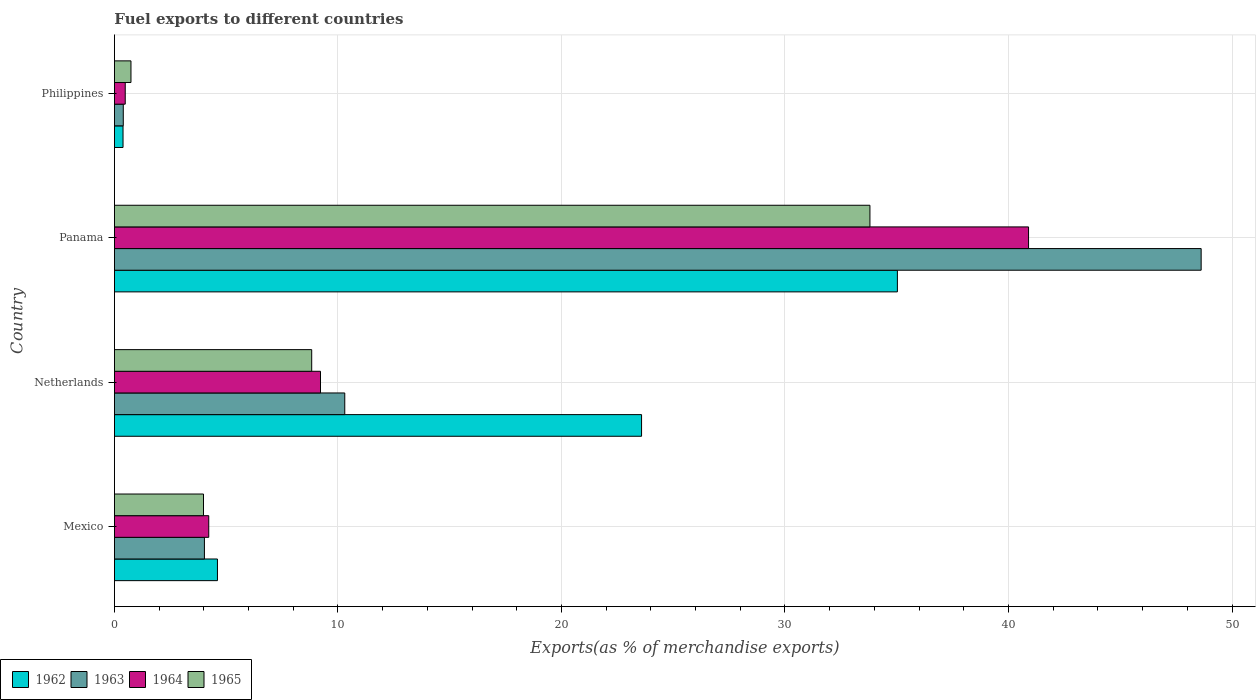How many different coloured bars are there?
Give a very brief answer. 4. Are the number of bars on each tick of the Y-axis equal?
Your answer should be compact. Yes. What is the label of the 1st group of bars from the top?
Give a very brief answer. Philippines. What is the percentage of exports to different countries in 1962 in Mexico?
Give a very brief answer. 4.61. Across all countries, what is the maximum percentage of exports to different countries in 1963?
Make the answer very short. 48.62. Across all countries, what is the minimum percentage of exports to different countries in 1962?
Ensure brevity in your answer.  0.38. In which country was the percentage of exports to different countries in 1964 maximum?
Provide a short and direct response. Panama. What is the total percentage of exports to different countries in 1963 in the graph?
Provide a short and direct response. 63.35. What is the difference between the percentage of exports to different countries in 1963 in Netherlands and that in Philippines?
Your response must be concise. 9.91. What is the difference between the percentage of exports to different countries in 1963 in Panama and the percentage of exports to different countries in 1962 in Netherlands?
Keep it short and to the point. 25.04. What is the average percentage of exports to different countries in 1965 per country?
Make the answer very short. 11.84. What is the difference between the percentage of exports to different countries in 1965 and percentage of exports to different countries in 1962 in Mexico?
Give a very brief answer. -0.62. What is the ratio of the percentage of exports to different countries in 1964 in Netherlands to that in Philippines?
Ensure brevity in your answer.  19.07. Is the percentage of exports to different countries in 1963 in Netherlands less than that in Philippines?
Offer a terse response. No. What is the difference between the highest and the second highest percentage of exports to different countries in 1965?
Offer a terse response. 24.98. What is the difference between the highest and the lowest percentage of exports to different countries in 1965?
Give a very brief answer. 33.06. Is it the case that in every country, the sum of the percentage of exports to different countries in 1965 and percentage of exports to different countries in 1964 is greater than the sum of percentage of exports to different countries in 1963 and percentage of exports to different countries in 1962?
Give a very brief answer. No. What does the 2nd bar from the top in Panama represents?
Keep it short and to the point. 1964. What does the 4th bar from the bottom in Philippines represents?
Keep it short and to the point. 1965. Are all the bars in the graph horizontal?
Ensure brevity in your answer.  Yes. How many countries are there in the graph?
Ensure brevity in your answer.  4. What is the difference between two consecutive major ticks on the X-axis?
Make the answer very short. 10. Are the values on the major ticks of X-axis written in scientific E-notation?
Ensure brevity in your answer.  No. Does the graph contain any zero values?
Make the answer very short. No. How many legend labels are there?
Your response must be concise. 4. How are the legend labels stacked?
Offer a very short reply. Horizontal. What is the title of the graph?
Your answer should be very brief. Fuel exports to different countries. Does "1985" appear as one of the legend labels in the graph?
Your answer should be very brief. No. What is the label or title of the X-axis?
Your response must be concise. Exports(as % of merchandise exports). What is the label or title of the Y-axis?
Provide a succinct answer. Country. What is the Exports(as % of merchandise exports) of 1962 in Mexico?
Offer a terse response. 4.61. What is the Exports(as % of merchandise exports) in 1963 in Mexico?
Give a very brief answer. 4.03. What is the Exports(as % of merchandise exports) of 1964 in Mexico?
Your response must be concise. 4.22. What is the Exports(as % of merchandise exports) of 1965 in Mexico?
Your answer should be compact. 3.99. What is the Exports(as % of merchandise exports) of 1962 in Netherlands?
Ensure brevity in your answer.  23.58. What is the Exports(as % of merchandise exports) of 1963 in Netherlands?
Offer a very short reply. 10.31. What is the Exports(as % of merchandise exports) of 1964 in Netherlands?
Provide a succinct answer. 9.22. What is the Exports(as % of merchandise exports) in 1965 in Netherlands?
Offer a very short reply. 8.83. What is the Exports(as % of merchandise exports) of 1962 in Panama?
Give a very brief answer. 35.03. What is the Exports(as % of merchandise exports) of 1963 in Panama?
Your answer should be very brief. 48.62. What is the Exports(as % of merchandise exports) of 1964 in Panama?
Make the answer very short. 40.9. What is the Exports(as % of merchandise exports) of 1965 in Panama?
Offer a terse response. 33.8. What is the Exports(as % of merchandise exports) in 1962 in Philippines?
Keep it short and to the point. 0.38. What is the Exports(as % of merchandise exports) of 1963 in Philippines?
Your answer should be compact. 0.4. What is the Exports(as % of merchandise exports) in 1964 in Philippines?
Your answer should be compact. 0.48. What is the Exports(as % of merchandise exports) in 1965 in Philippines?
Your answer should be very brief. 0.74. Across all countries, what is the maximum Exports(as % of merchandise exports) of 1962?
Your answer should be compact. 35.03. Across all countries, what is the maximum Exports(as % of merchandise exports) of 1963?
Offer a terse response. 48.62. Across all countries, what is the maximum Exports(as % of merchandise exports) of 1964?
Make the answer very short. 40.9. Across all countries, what is the maximum Exports(as % of merchandise exports) of 1965?
Give a very brief answer. 33.8. Across all countries, what is the minimum Exports(as % of merchandise exports) in 1962?
Offer a terse response. 0.38. Across all countries, what is the minimum Exports(as % of merchandise exports) in 1963?
Offer a terse response. 0.4. Across all countries, what is the minimum Exports(as % of merchandise exports) in 1964?
Offer a very short reply. 0.48. Across all countries, what is the minimum Exports(as % of merchandise exports) in 1965?
Your answer should be compact. 0.74. What is the total Exports(as % of merchandise exports) of 1962 in the graph?
Provide a succinct answer. 63.61. What is the total Exports(as % of merchandise exports) in 1963 in the graph?
Offer a very short reply. 63.35. What is the total Exports(as % of merchandise exports) in 1964 in the graph?
Your answer should be compact. 54.82. What is the total Exports(as % of merchandise exports) in 1965 in the graph?
Keep it short and to the point. 47.35. What is the difference between the Exports(as % of merchandise exports) in 1962 in Mexico and that in Netherlands?
Offer a very short reply. -18.97. What is the difference between the Exports(as % of merchandise exports) in 1963 in Mexico and that in Netherlands?
Provide a succinct answer. -6.28. What is the difference between the Exports(as % of merchandise exports) in 1964 in Mexico and that in Netherlands?
Your answer should be compact. -5. What is the difference between the Exports(as % of merchandise exports) of 1965 in Mexico and that in Netherlands?
Provide a short and direct response. -4.84. What is the difference between the Exports(as % of merchandise exports) of 1962 in Mexico and that in Panama?
Offer a very short reply. -30.42. What is the difference between the Exports(as % of merchandise exports) in 1963 in Mexico and that in Panama?
Your answer should be compact. -44.59. What is the difference between the Exports(as % of merchandise exports) in 1964 in Mexico and that in Panama?
Provide a succinct answer. -36.68. What is the difference between the Exports(as % of merchandise exports) in 1965 in Mexico and that in Panama?
Your answer should be very brief. -29.82. What is the difference between the Exports(as % of merchandise exports) of 1962 in Mexico and that in Philippines?
Your answer should be compact. 4.22. What is the difference between the Exports(as % of merchandise exports) of 1963 in Mexico and that in Philippines?
Your response must be concise. 3.63. What is the difference between the Exports(as % of merchandise exports) in 1964 in Mexico and that in Philippines?
Offer a very short reply. 3.74. What is the difference between the Exports(as % of merchandise exports) in 1965 in Mexico and that in Philippines?
Make the answer very short. 3.25. What is the difference between the Exports(as % of merchandise exports) in 1962 in Netherlands and that in Panama?
Keep it short and to the point. -11.45. What is the difference between the Exports(as % of merchandise exports) in 1963 in Netherlands and that in Panama?
Offer a terse response. -38.32. What is the difference between the Exports(as % of merchandise exports) in 1964 in Netherlands and that in Panama?
Your answer should be very brief. -31.68. What is the difference between the Exports(as % of merchandise exports) of 1965 in Netherlands and that in Panama?
Make the answer very short. -24.98. What is the difference between the Exports(as % of merchandise exports) in 1962 in Netherlands and that in Philippines?
Your response must be concise. 23.2. What is the difference between the Exports(as % of merchandise exports) of 1963 in Netherlands and that in Philippines?
Offer a very short reply. 9.91. What is the difference between the Exports(as % of merchandise exports) of 1964 in Netherlands and that in Philippines?
Your response must be concise. 8.74. What is the difference between the Exports(as % of merchandise exports) in 1965 in Netherlands and that in Philippines?
Make the answer very short. 8.09. What is the difference between the Exports(as % of merchandise exports) in 1962 in Panama and that in Philippines?
Ensure brevity in your answer.  34.65. What is the difference between the Exports(as % of merchandise exports) in 1963 in Panama and that in Philippines?
Your response must be concise. 48.22. What is the difference between the Exports(as % of merchandise exports) in 1964 in Panama and that in Philippines?
Your response must be concise. 40.41. What is the difference between the Exports(as % of merchandise exports) in 1965 in Panama and that in Philippines?
Your answer should be very brief. 33.06. What is the difference between the Exports(as % of merchandise exports) in 1962 in Mexico and the Exports(as % of merchandise exports) in 1963 in Netherlands?
Ensure brevity in your answer.  -5.7. What is the difference between the Exports(as % of merchandise exports) in 1962 in Mexico and the Exports(as % of merchandise exports) in 1964 in Netherlands?
Keep it short and to the point. -4.61. What is the difference between the Exports(as % of merchandise exports) of 1962 in Mexico and the Exports(as % of merchandise exports) of 1965 in Netherlands?
Make the answer very short. -4.22. What is the difference between the Exports(as % of merchandise exports) of 1963 in Mexico and the Exports(as % of merchandise exports) of 1964 in Netherlands?
Provide a short and direct response. -5.19. What is the difference between the Exports(as % of merchandise exports) in 1963 in Mexico and the Exports(as % of merchandise exports) in 1965 in Netherlands?
Ensure brevity in your answer.  -4.8. What is the difference between the Exports(as % of merchandise exports) of 1964 in Mexico and the Exports(as % of merchandise exports) of 1965 in Netherlands?
Give a very brief answer. -4.61. What is the difference between the Exports(as % of merchandise exports) of 1962 in Mexico and the Exports(as % of merchandise exports) of 1963 in Panama?
Provide a succinct answer. -44.01. What is the difference between the Exports(as % of merchandise exports) of 1962 in Mexico and the Exports(as % of merchandise exports) of 1964 in Panama?
Offer a very short reply. -36.29. What is the difference between the Exports(as % of merchandise exports) of 1962 in Mexico and the Exports(as % of merchandise exports) of 1965 in Panama?
Keep it short and to the point. -29.19. What is the difference between the Exports(as % of merchandise exports) of 1963 in Mexico and the Exports(as % of merchandise exports) of 1964 in Panama?
Provide a short and direct response. -36.87. What is the difference between the Exports(as % of merchandise exports) in 1963 in Mexico and the Exports(as % of merchandise exports) in 1965 in Panama?
Ensure brevity in your answer.  -29.78. What is the difference between the Exports(as % of merchandise exports) in 1964 in Mexico and the Exports(as % of merchandise exports) in 1965 in Panama?
Your answer should be very brief. -29.58. What is the difference between the Exports(as % of merchandise exports) of 1962 in Mexico and the Exports(as % of merchandise exports) of 1963 in Philippines?
Offer a very short reply. 4.21. What is the difference between the Exports(as % of merchandise exports) in 1962 in Mexico and the Exports(as % of merchandise exports) in 1964 in Philippines?
Provide a succinct answer. 4.13. What is the difference between the Exports(as % of merchandise exports) of 1962 in Mexico and the Exports(as % of merchandise exports) of 1965 in Philippines?
Your answer should be very brief. 3.87. What is the difference between the Exports(as % of merchandise exports) of 1963 in Mexico and the Exports(as % of merchandise exports) of 1964 in Philippines?
Ensure brevity in your answer.  3.54. What is the difference between the Exports(as % of merchandise exports) in 1963 in Mexico and the Exports(as % of merchandise exports) in 1965 in Philippines?
Offer a very short reply. 3.29. What is the difference between the Exports(as % of merchandise exports) of 1964 in Mexico and the Exports(as % of merchandise exports) of 1965 in Philippines?
Your answer should be compact. 3.48. What is the difference between the Exports(as % of merchandise exports) of 1962 in Netherlands and the Exports(as % of merchandise exports) of 1963 in Panama?
Give a very brief answer. -25.04. What is the difference between the Exports(as % of merchandise exports) in 1962 in Netherlands and the Exports(as % of merchandise exports) in 1964 in Panama?
Keep it short and to the point. -17.31. What is the difference between the Exports(as % of merchandise exports) in 1962 in Netherlands and the Exports(as % of merchandise exports) in 1965 in Panama?
Your answer should be compact. -10.22. What is the difference between the Exports(as % of merchandise exports) of 1963 in Netherlands and the Exports(as % of merchandise exports) of 1964 in Panama?
Give a very brief answer. -30.59. What is the difference between the Exports(as % of merchandise exports) of 1963 in Netherlands and the Exports(as % of merchandise exports) of 1965 in Panama?
Offer a terse response. -23.5. What is the difference between the Exports(as % of merchandise exports) of 1964 in Netherlands and the Exports(as % of merchandise exports) of 1965 in Panama?
Your answer should be compact. -24.58. What is the difference between the Exports(as % of merchandise exports) in 1962 in Netherlands and the Exports(as % of merchandise exports) in 1963 in Philippines?
Provide a succinct answer. 23.19. What is the difference between the Exports(as % of merchandise exports) of 1962 in Netherlands and the Exports(as % of merchandise exports) of 1964 in Philippines?
Offer a terse response. 23.1. What is the difference between the Exports(as % of merchandise exports) of 1962 in Netherlands and the Exports(as % of merchandise exports) of 1965 in Philippines?
Your answer should be very brief. 22.84. What is the difference between the Exports(as % of merchandise exports) of 1963 in Netherlands and the Exports(as % of merchandise exports) of 1964 in Philippines?
Provide a short and direct response. 9.82. What is the difference between the Exports(as % of merchandise exports) of 1963 in Netherlands and the Exports(as % of merchandise exports) of 1965 in Philippines?
Your response must be concise. 9.57. What is the difference between the Exports(as % of merchandise exports) in 1964 in Netherlands and the Exports(as % of merchandise exports) in 1965 in Philippines?
Provide a succinct answer. 8.48. What is the difference between the Exports(as % of merchandise exports) in 1962 in Panama and the Exports(as % of merchandise exports) in 1963 in Philippines?
Ensure brevity in your answer.  34.63. What is the difference between the Exports(as % of merchandise exports) of 1962 in Panama and the Exports(as % of merchandise exports) of 1964 in Philippines?
Your answer should be compact. 34.55. What is the difference between the Exports(as % of merchandise exports) of 1962 in Panama and the Exports(as % of merchandise exports) of 1965 in Philippines?
Offer a very short reply. 34.29. What is the difference between the Exports(as % of merchandise exports) in 1963 in Panama and the Exports(as % of merchandise exports) in 1964 in Philippines?
Provide a succinct answer. 48.14. What is the difference between the Exports(as % of merchandise exports) of 1963 in Panama and the Exports(as % of merchandise exports) of 1965 in Philippines?
Offer a terse response. 47.88. What is the difference between the Exports(as % of merchandise exports) of 1964 in Panama and the Exports(as % of merchandise exports) of 1965 in Philippines?
Give a very brief answer. 40.16. What is the average Exports(as % of merchandise exports) of 1962 per country?
Keep it short and to the point. 15.9. What is the average Exports(as % of merchandise exports) of 1963 per country?
Offer a terse response. 15.84. What is the average Exports(as % of merchandise exports) of 1964 per country?
Your response must be concise. 13.71. What is the average Exports(as % of merchandise exports) in 1965 per country?
Provide a short and direct response. 11.84. What is the difference between the Exports(as % of merchandise exports) in 1962 and Exports(as % of merchandise exports) in 1963 in Mexico?
Make the answer very short. 0.58. What is the difference between the Exports(as % of merchandise exports) in 1962 and Exports(as % of merchandise exports) in 1964 in Mexico?
Give a very brief answer. 0.39. What is the difference between the Exports(as % of merchandise exports) of 1962 and Exports(as % of merchandise exports) of 1965 in Mexico?
Offer a terse response. 0.62. What is the difference between the Exports(as % of merchandise exports) of 1963 and Exports(as % of merchandise exports) of 1964 in Mexico?
Offer a terse response. -0.19. What is the difference between the Exports(as % of merchandise exports) of 1963 and Exports(as % of merchandise exports) of 1965 in Mexico?
Provide a succinct answer. 0.04. What is the difference between the Exports(as % of merchandise exports) of 1964 and Exports(as % of merchandise exports) of 1965 in Mexico?
Provide a succinct answer. 0.23. What is the difference between the Exports(as % of merchandise exports) of 1962 and Exports(as % of merchandise exports) of 1963 in Netherlands?
Your answer should be very brief. 13.28. What is the difference between the Exports(as % of merchandise exports) in 1962 and Exports(as % of merchandise exports) in 1964 in Netherlands?
Provide a succinct answer. 14.36. What is the difference between the Exports(as % of merchandise exports) in 1962 and Exports(as % of merchandise exports) in 1965 in Netherlands?
Your answer should be compact. 14.76. What is the difference between the Exports(as % of merchandise exports) of 1963 and Exports(as % of merchandise exports) of 1964 in Netherlands?
Make the answer very short. 1.09. What is the difference between the Exports(as % of merchandise exports) of 1963 and Exports(as % of merchandise exports) of 1965 in Netherlands?
Your answer should be compact. 1.48. What is the difference between the Exports(as % of merchandise exports) of 1964 and Exports(as % of merchandise exports) of 1965 in Netherlands?
Your answer should be compact. 0.39. What is the difference between the Exports(as % of merchandise exports) of 1962 and Exports(as % of merchandise exports) of 1963 in Panama?
Provide a short and direct response. -13.59. What is the difference between the Exports(as % of merchandise exports) of 1962 and Exports(as % of merchandise exports) of 1964 in Panama?
Provide a short and direct response. -5.87. What is the difference between the Exports(as % of merchandise exports) in 1962 and Exports(as % of merchandise exports) in 1965 in Panama?
Your answer should be very brief. 1.23. What is the difference between the Exports(as % of merchandise exports) of 1963 and Exports(as % of merchandise exports) of 1964 in Panama?
Your answer should be very brief. 7.72. What is the difference between the Exports(as % of merchandise exports) of 1963 and Exports(as % of merchandise exports) of 1965 in Panama?
Provide a short and direct response. 14.82. What is the difference between the Exports(as % of merchandise exports) in 1964 and Exports(as % of merchandise exports) in 1965 in Panama?
Provide a short and direct response. 7.1. What is the difference between the Exports(as % of merchandise exports) of 1962 and Exports(as % of merchandise exports) of 1963 in Philippines?
Offer a very short reply. -0.01. What is the difference between the Exports(as % of merchandise exports) of 1962 and Exports(as % of merchandise exports) of 1964 in Philippines?
Provide a short and direct response. -0.1. What is the difference between the Exports(as % of merchandise exports) of 1962 and Exports(as % of merchandise exports) of 1965 in Philippines?
Provide a succinct answer. -0.35. What is the difference between the Exports(as % of merchandise exports) in 1963 and Exports(as % of merchandise exports) in 1964 in Philippines?
Your response must be concise. -0.09. What is the difference between the Exports(as % of merchandise exports) in 1963 and Exports(as % of merchandise exports) in 1965 in Philippines?
Keep it short and to the point. -0.34. What is the difference between the Exports(as % of merchandise exports) of 1964 and Exports(as % of merchandise exports) of 1965 in Philippines?
Ensure brevity in your answer.  -0.26. What is the ratio of the Exports(as % of merchandise exports) in 1962 in Mexico to that in Netherlands?
Your answer should be very brief. 0.2. What is the ratio of the Exports(as % of merchandise exports) in 1963 in Mexico to that in Netherlands?
Your response must be concise. 0.39. What is the ratio of the Exports(as % of merchandise exports) of 1964 in Mexico to that in Netherlands?
Your answer should be compact. 0.46. What is the ratio of the Exports(as % of merchandise exports) in 1965 in Mexico to that in Netherlands?
Your answer should be compact. 0.45. What is the ratio of the Exports(as % of merchandise exports) of 1962 in Mexico to that in Panama?
Provide a short and direct response. 0.13. What is the ratio of the Exports(as % of merchandise exports) in 1963 in Mexico to that in Panama?
Your answer should be very brief. 0.08. What is the ratio of the Exports(as % of merchandise exports) in 1964 in Mexico to that in Panama?
Your answer should be compact. 0.1. What is the ratio of the Exports(as % of merchandise exports) of 1965 in Mexico to that in Panama?
Your answer should be compact. 0.12. What is the ratio of the Exports(as % of merchandise exports) of 1962 in Mexico to that in Philippines?
Keep it short and to the point. 11.97. What is the ratio of the Exports(as % of merchandise exports) in 1963 in Mexico to that in Philippines?
Give a very brief answer. 10.17. What is the ratio of the Exports(as % of merchandise exports) of 1964 in Mexico to that in Philippines?
Your response must be concise. 8.73. What is the ratio of the Exports(as % of merchandise exports) in 1965 in Mexico to that in Philippines?
Ensure brevity in your answer.  5.39. What is the ratio of the Exports(as % of merchandise exports) in 1962 in Netherlands to that in Panama?
Your answer should be very brief. 0.67. What is the ratio of the Exports(as % of merchandise exports) in 1963 in Netherlands to that in Panama?
Your answer should be very brief. 0.21. What is the ratio of the Exports(as % of merchandise exports) in 1964 in Netherlands to that in Panama?
Make the answer very short. 0.23. What is the ratio of the Exports(as % of merchandise exports) of 1965 in Netherlands to that in Panama?
Offer a very short reply. 0.26. What is the ratio of the Exports(as % of merchandise exports) in 1962 in Netherlands to that in Philippines?
Your answer should be compact. 61.27. What is the ratio of the Exports(as % of merchandise exports) of 1963 in Netherlands to that in Philippines?
Provide a succinct answer. 26.03. What is the ratio of the Exports(as % of merchandise exports) of 1964 in Netherlands to that in Philippines?
Offer a very short reply. 19.07. What is the ratio of the Exports(as % of merchandise exports) in 1965 in Netherlands to that in Philippines?
Provide a succinct answer. 11.93. What is the ratio of the Exports(as % of merchandise exports) of 1962 in Panama to that in Philippines?
Offer a terse response. 91.01. What is the ratio of the Exports(as % of merchandise exports) in 1963 in Panama to that in Philippines?
Your answer should be very brief. 122.82. What is the ratio of the Exports(as % of merchandise exports) of 1964 in Panama to that in Philippines?
Make the answer very short. 84.6. What is the ratio of the Exports(as % of merchandise exports) of 1965 in Panama to that in Philippines?
Offer a terse response. 45.69. What is the difference between the highest and the second highest Exports(as % of merchandise exports) in 1962?
Make the answer very short. 11.45. What is the difference between the highest and the second highest Exports(as % of merchandise exports) of 1963?
Give a very brief answer. 38.32. What is the difference between the highest and the second highest Exports(as % of merchandise exports) of 1964?
Give a very brief answer. 31.68. What is the difference between the highest and the second highest Exports(as % of merchandise exports) of 1965?
Offer a very short reply. 24.98. What is the difference between the highest and the lowest Exports(as % of merchandise exports) of 1962?
Ensure brevity in your answer.  34.65. What is the difference between the highest and the lowest Exports(as % of merchandise exports) of 1963?
Offer a terse response. 48.22. What is the difference between the highest and the lowest Exports(as % of merchandise exports) in 1964?
Your answer should be very brief. 40.41. What is the difference between the highest and the lowest Exports(as % of merchandise exports) in 1965?
Ensure brevity in your answer.  33.06. 